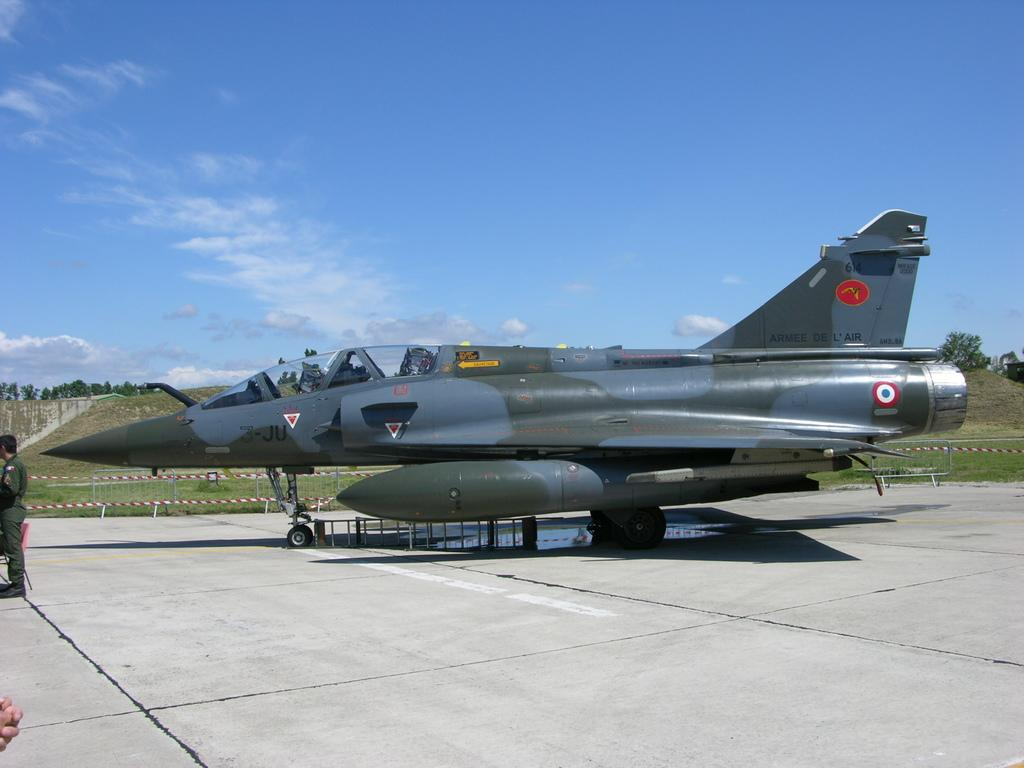What is the main subject of the image? There is an aircraft in the image. What is the color of the grass in the image? There is green grass on the ground in some areas. Can you describe the person in the image? There is a person standing at the left side of the image. What color is the sky in the image? The sky is blue at the top of the image. What type of copper material can be seen smashed on the ground in the image? There is no copper material or smashing present in the image. 